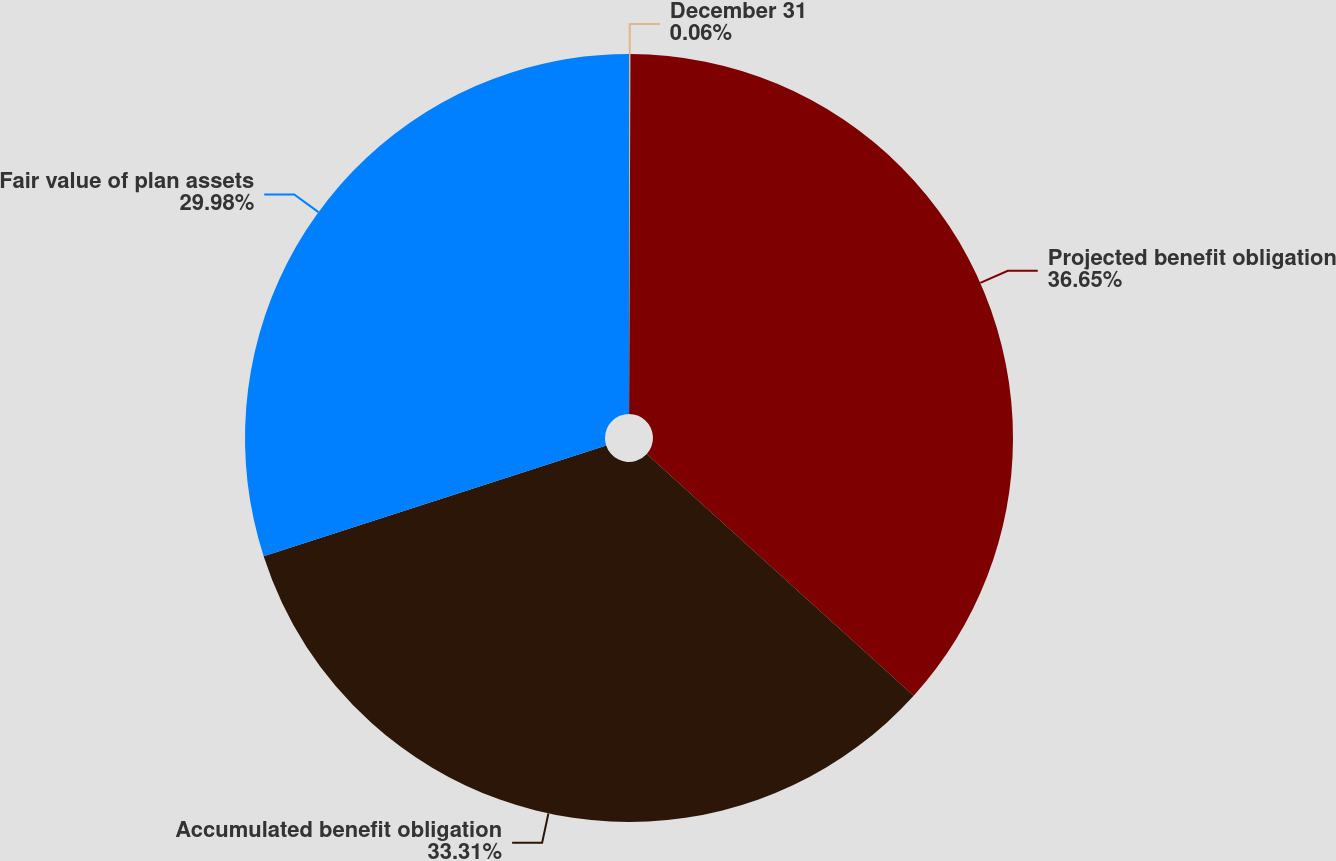Convert chart. <chart><loc_0><loc_0><loc_500><loc_500><pie_chart><fcel>December 31<fcel>Projected benefit obligation<fcel>Accumulated benefit obligation<fcel>Fair value of plan assets<nl><fcel>0.06%<fcel>36.65%<fcel>33.31%<fcel>29.98%<nl></chart> 